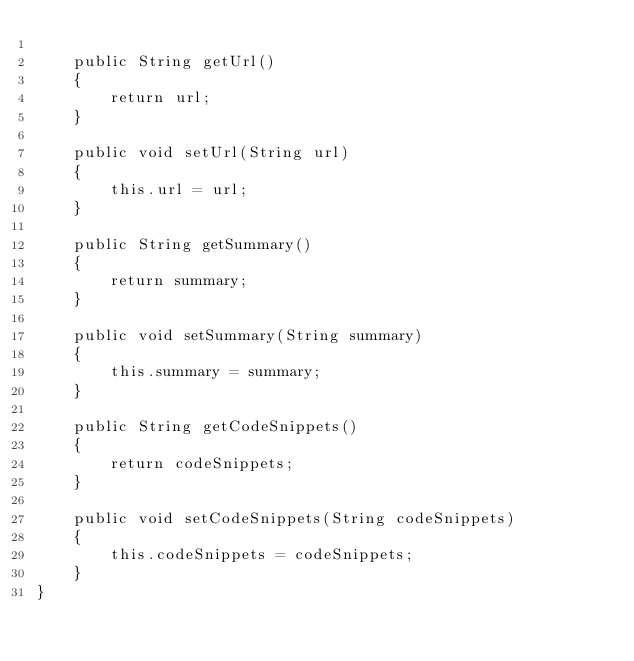Convert code to text. <code><loc_0><loc_0><loc_500><loc_500><_Java_>
    public String getUrl()
    {
        return url;
    }

    public void setUrl(String url)
    {
        this.url = url;
    }

    public String getSummary()
    {
        return summary;
    }

    public void setSummary(String summary)
    {
        this.summary = summary;
    }

    public String getCodeSnippets()
    {
        return codeSnippets;
    }

    public void setCodeSnippets(String codeSnippets)
    {
        this.codeSnippets = codeSnippets;
    }
}
</code> 